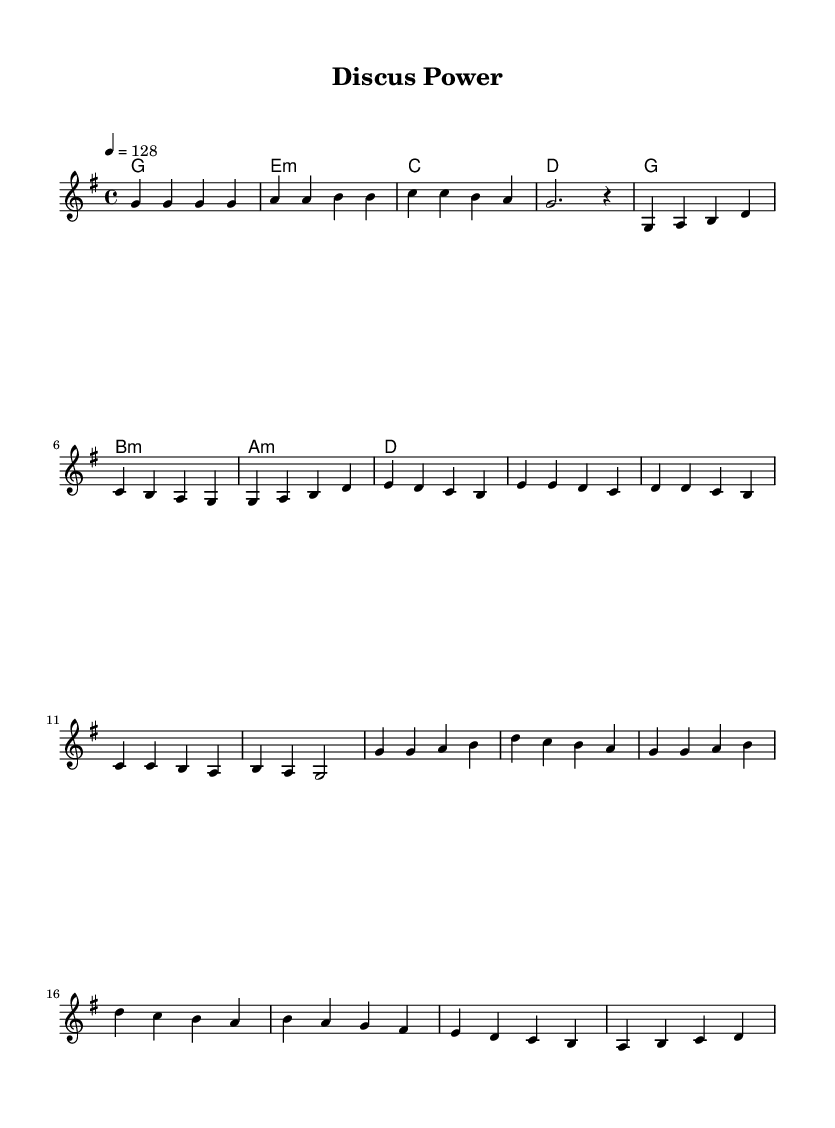What is the key signature of this music? The key signature is indicated at the beginning of the score. In this case, G major has one sharp (F#).
Answer: G major What is the time signature of this piece? The time signature is shown at the beginning of the score as well. It is written in the form of a fraction: 4/4.
Answer: 4/4 What is the tempo marking for this music? The tempo marking is specified with a number indicating beats per minute at the beginning. Here, it is set at 128 beats per minute.
Answer: 128 What is the starting note of the melody? The starting note is the first note in the melody line. In this score, it is G.
Answer: G How many measures are in the chorus section? To determine this, we can count the measures indicated in the chorus section specifically in the score. The chorus contains four measures.
Answer: 4 What is the final harmony chord used? The final chord can be found in the harmonies section at the end. The last chord is D major.
Answer: D What is the predominant emotion conveyed through the music style? K-Pop music often aims to convey a lively and energetic vibe, which is evident through the upbeat tempo and rhythmic structure of this track.
Answer: Energetic 